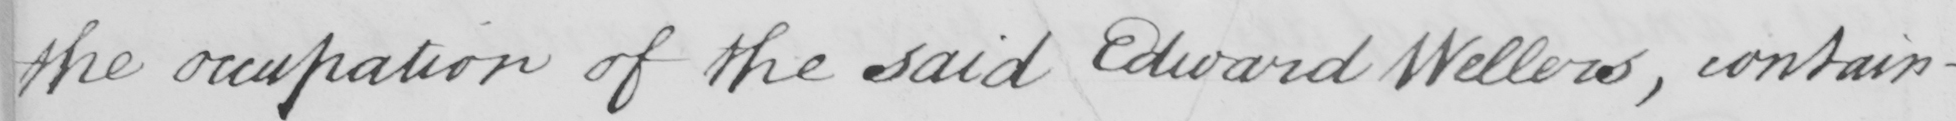Can you read and transcribe this handwriting? the occupation of the said Edward Wellers , contain- 